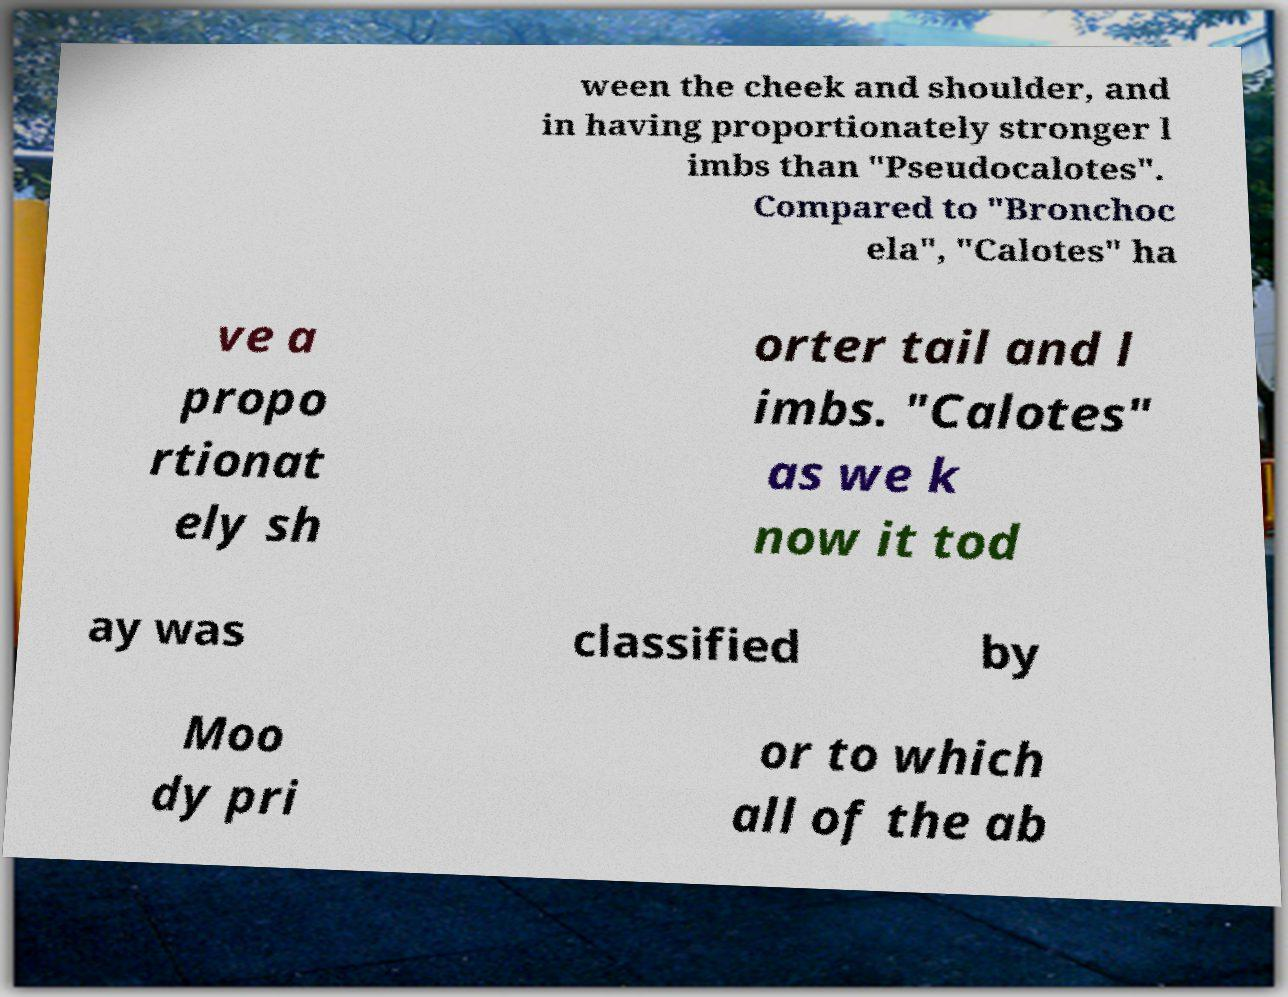I need the written content from this picture converted into text. Can you do that? ween the cheek and shoulder, and in having proportionately stronger l imbs than "Pseudocalotes". Compared to "Bronchoc ela", "Calotes" ha ve a propo rtionat ely sh orter tail and l imbs. "Calotes" as we k now it tod ay was classified by Moo dy pri or to which all of the ab 